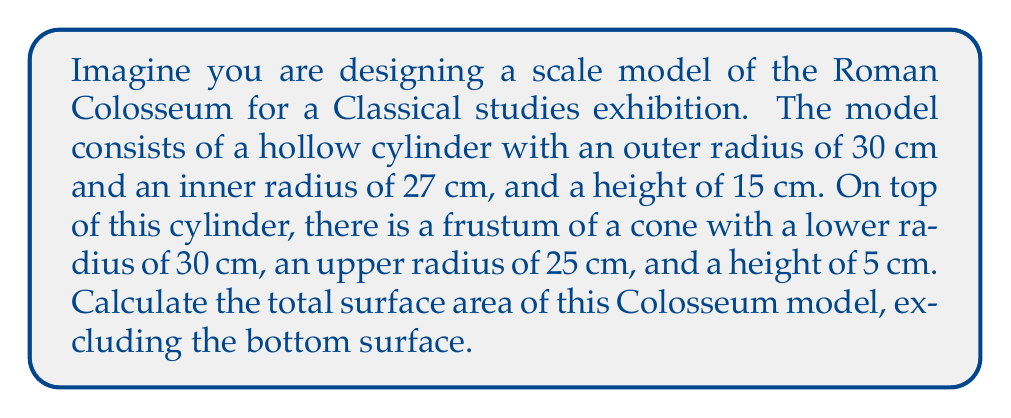Teach me how to tackle this problem. Let's approach this step-by-step:

1) First, we need to calculate the surface area of the hollow cylinder:
   a) Outer lateral surface area: $A_{outer} = 2\pi r_1 h = 2\pi(30)(15) = 900\pi$ cm²
   b) Inner lateral surface area: $A_{inner} = 2\pi r_2 h = 2\pi(27)(15) = 810\pi$ cm²
   c) Top circular ring: $A_{ring} = \pi(r_1^2 - r_2^2) = \pi(30^2 - 27^2) = 171\pi$ cm²

2) Now, let's calculate the surface area of the frustum:
   a) Lateral surface area: $A_{frustum} = \pi(r_1 + r_2)\sqrt{h^2 + (r_1 - r_2)^2}$
      Where $r_1 = 30$ cm, $r_2 = 25$ cm, and $h = 5$ cm
      $A_{frustum} = \pi(30 + 25)\sqrt{5^2 + (30 - 25)^2} = 55\pi\sqrt{50}$ cm²
   b) Top circular surface: $A_{top} = \pi r_2^2 = \pi(25^2) = 625\pi$ cm²

3) Total surface area:
   $A_{total} = A_{outer} + A_{inner} + A_{ring} + A_{frustum} + A_{top}$
   $A_{total} = 900\pi + 810\pi + 171\pi + 55\pi\sqrt{50} + 625\pi$
   $A_{total} = (2506 + 55\sqrt{50})\pi$ cm²
Answer: $(2506 + 55\sqrt{50})\pi$ cm² 